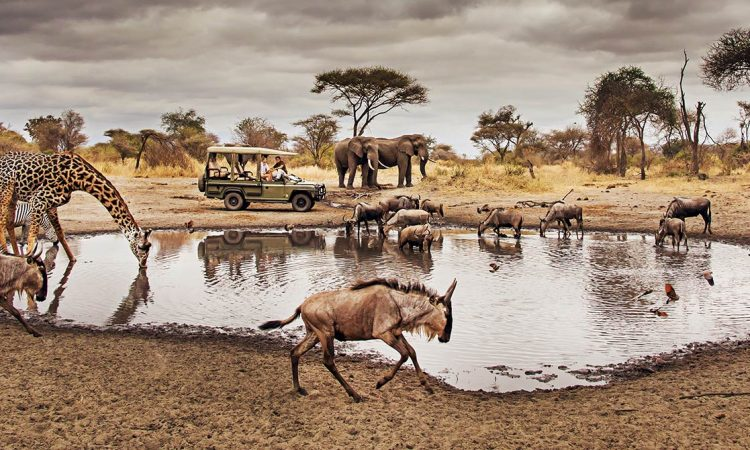Can you describe the behavior of the animals in this scene? In this scene, the animals are primarily engaging in a crucial activity—gathering around a watering hole to drink. The watering hole acts as a magnet for a variety of wildlife, particularly in the heat and dryness of the savannah. The giraffe on the left is cautiously moving towards the safari vehicle, possibly driven by curiosity or the hope of finding more food sources. The wildebeests are seen drinking water while being vigilant of their surroundings for any potential predators. The elephants in the background appear calm and relaxed, suggesting they might have just finished drinking or are about to partake. This image beautifully captures the symbiotic relationship of these animals with their habitat and their instinctual behavior to ensure survival. What might the tourists in the safari vehicle be experiencing or feeling? The tourists inside the safari vehicle are likely experiencing a mixture of awe, excitement, and a sense of adventure. For many, witnessing such diverse and majestic wildlife in their natural habitat is a once-in-a-lifetime experience. They may be eagerly taking photographs, keen to capture the unique behavior and interactions of the animals. The proximity of the giraffe to their vehicle could be particularly thrilling, offering a close-up view that highlights the magnificent size and grace of this gentle giant. This moment allows them to feel connected to nature, offering a stark contrast to their everyday lives, and may even induce a contemplative mood as they witness the raw beauty and inherent challenges of animal life in the wild. 